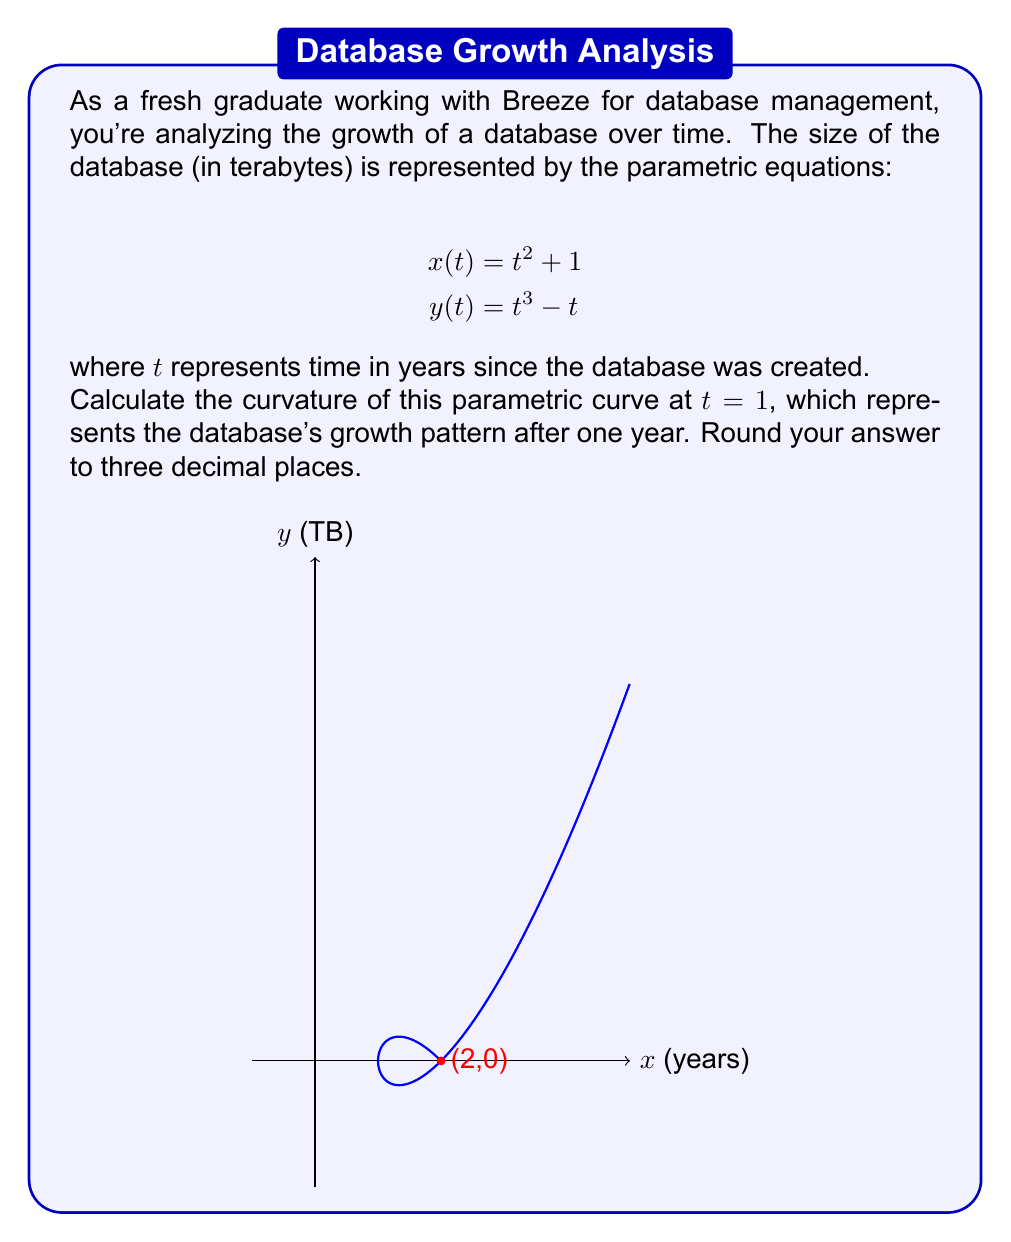Show me your answer to this math problem. To calculate the curvature of a parametric curve, we'll use the formula:

$$\kappa = \frac{|x'y'' - y'x''|}{(x'^2 + y'^2)^{3/2}}$$

Let's solve this step-by-step:

1) First, we need to find $x'(t)$, $y'(t)$, $x''(t)$, and $y''(t)$:

   $x'(t) = 2t$
   $y'(t) = 3t^2 - 1$
   $x''(t) = 2$
   $y''(t) = 6t$

2) Now, let's substitute $t = 1$ into these expressions:

   $x'(1) = 2$
   $y'(1) = 2$
   $x''(1) = 2$
   $y''(1) = 6$

3) Let's calculate the numerator $|x'y'' - y'x''|$:

   $|x'y'' - y'x''| = |2(6) - 2(2)| = |12 - 4| = 8$

4) Now for the denominator $(x'^2 + y'^2)^{3/2}$:

   $(x'^2 + y'^2)^{3/2} = (2^2 + 2^2)^{3/2} = 8^{3/2} = 8\sqrt{8}$

5) Putting it all together:

   $$\kappa = \frac{8}{8\sqrt{8}} = \frac{1}{\sqrt{8}} = \frac{\sqrt{8}}{8} \approx 0.354$$

6) Rounding to three decimal places gives us 0.354.
Answer: $0.354$ 